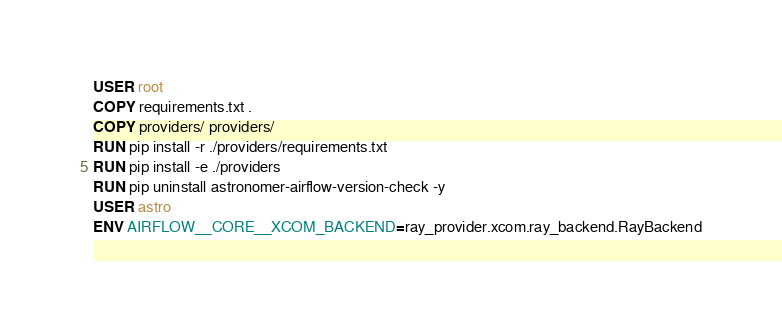Convert code to text. <code><loc_0><loc_0><loc_500><loc_500><_Dockerfile_>USER root
COPY requirements.txt .
COPY providers/ providers/
RUN pip install -r ./providers/requirements.txt
RUN pip install -e ./providers
RUN pip uninstall astronomer-airflow-version-check -y
USER astro
ENV AIRFLOW__CORE__XCOM_BACKEND=ray_provider.xcom.ray_backend.RayBackend</code> 